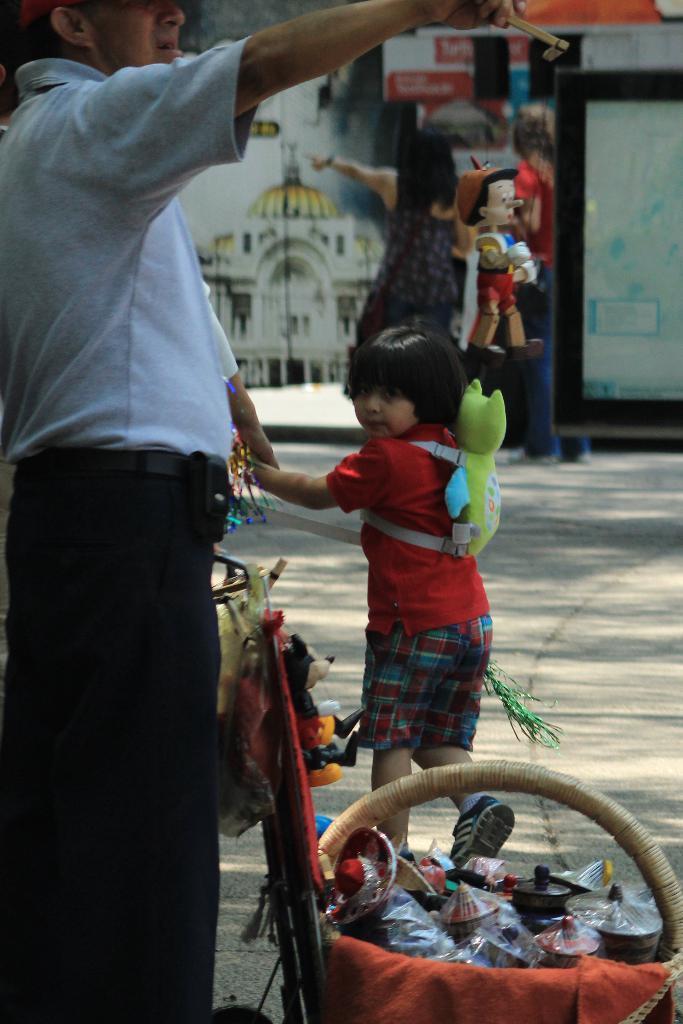Can you describe this image briefly? On the left side of the image we can see one person is standing and he is holding some objects. In front of him, we can see one baby wheelchair. In the baby wheelchair, we can see some objects. In the center of the image we can see one kid is walking and wearing a green bag. And we can see the kid is holding one person hand. In the background there is a wall, one cartoon character, two persons are standing, banners and a few other objects. 